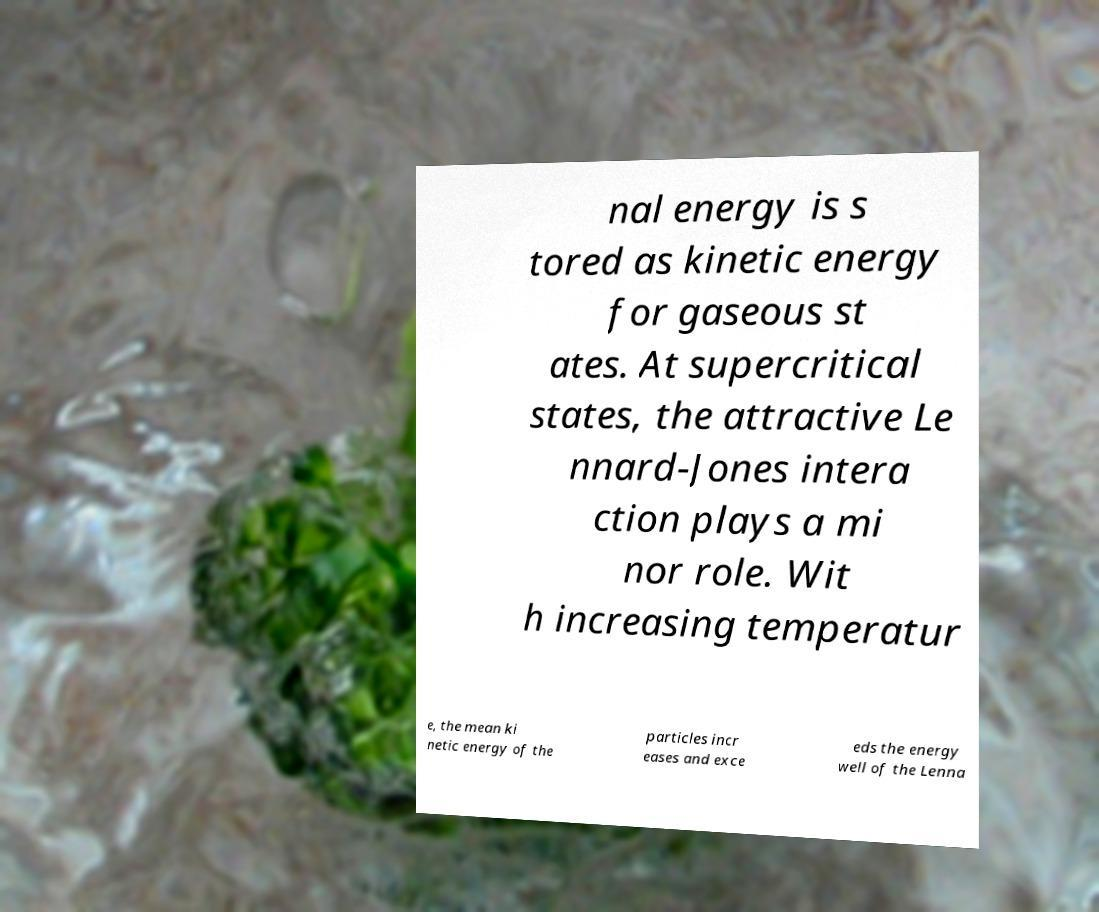Could you assist in decoding the text presented in this image and type it out clearly? nal energy is s tored as kinetic energy for gaseous st ates. At supercritical states, the attractive Le nnard-Jones intera ction plays a mi nor role. Wit h increasing temperatur e, the mean ki netic energy of the particles incr eases and exce eds the energy well of the Lenna 